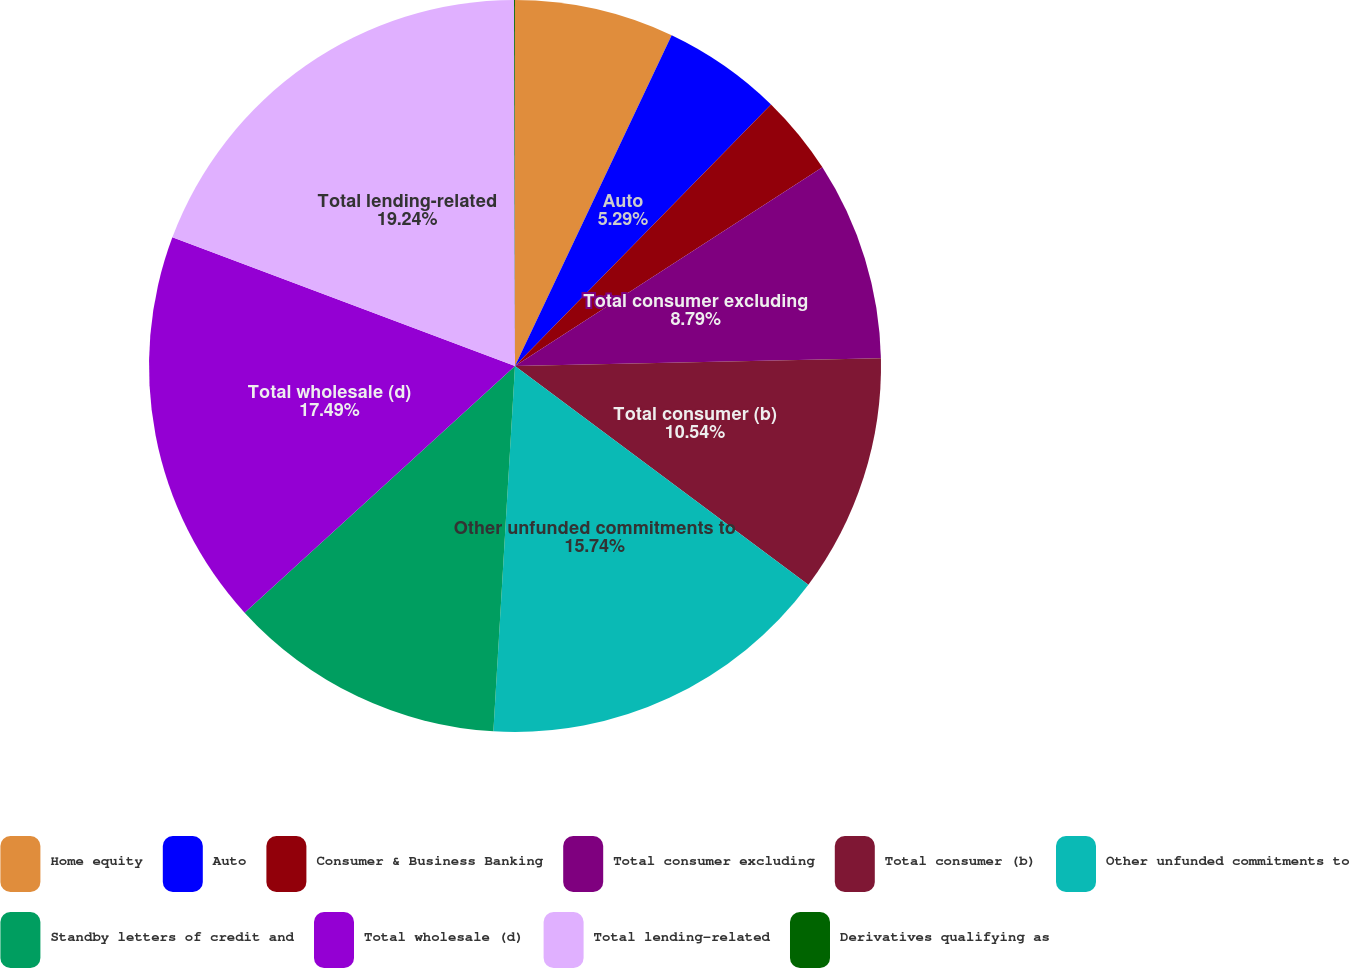<chart> <loc_0><loc_0><loc_500><loc_500><pie_chart><fcel>Home equity<fcel>Auto<fcel>Consumer & Business Banking<fcel>Total consumer excluding<fcel>Total consumer (b)<fcel>Other unfunded commitments to<fcel>Standby letters of credit and<fcel>Total wholesale (d)<fcel>Total lending-related<fcel>Derivatives qualifying as<nl><fcel>7.04%<fcel>5.29%<fcel>3.54%<fcel>8.79%<fcel>10.54%<fcel>15.74%<fcel>12.29%<fcel>17.49%<fcel>19.24%<fcel>0.04%<nl></chart> 